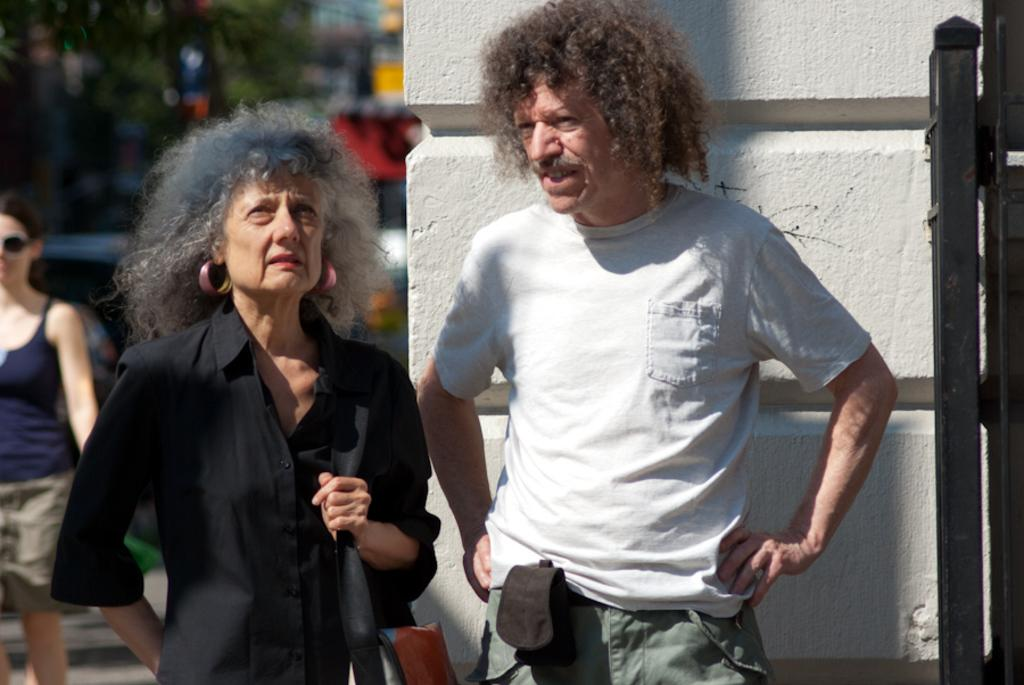What are the people in the image doing? The people in the image are standing on the road. What else can be seen on the road besides the people? Motor vehicles are present on the road. What type of natural elements can be seen in the image? There are trees visible in the image. What type of man-made structures can be seen in the image? There are walls in the image. What color is the copy of the book on the wall in the image? There is no book or copy present in the image; it only features people, motor vehicles, trees, and walls. 